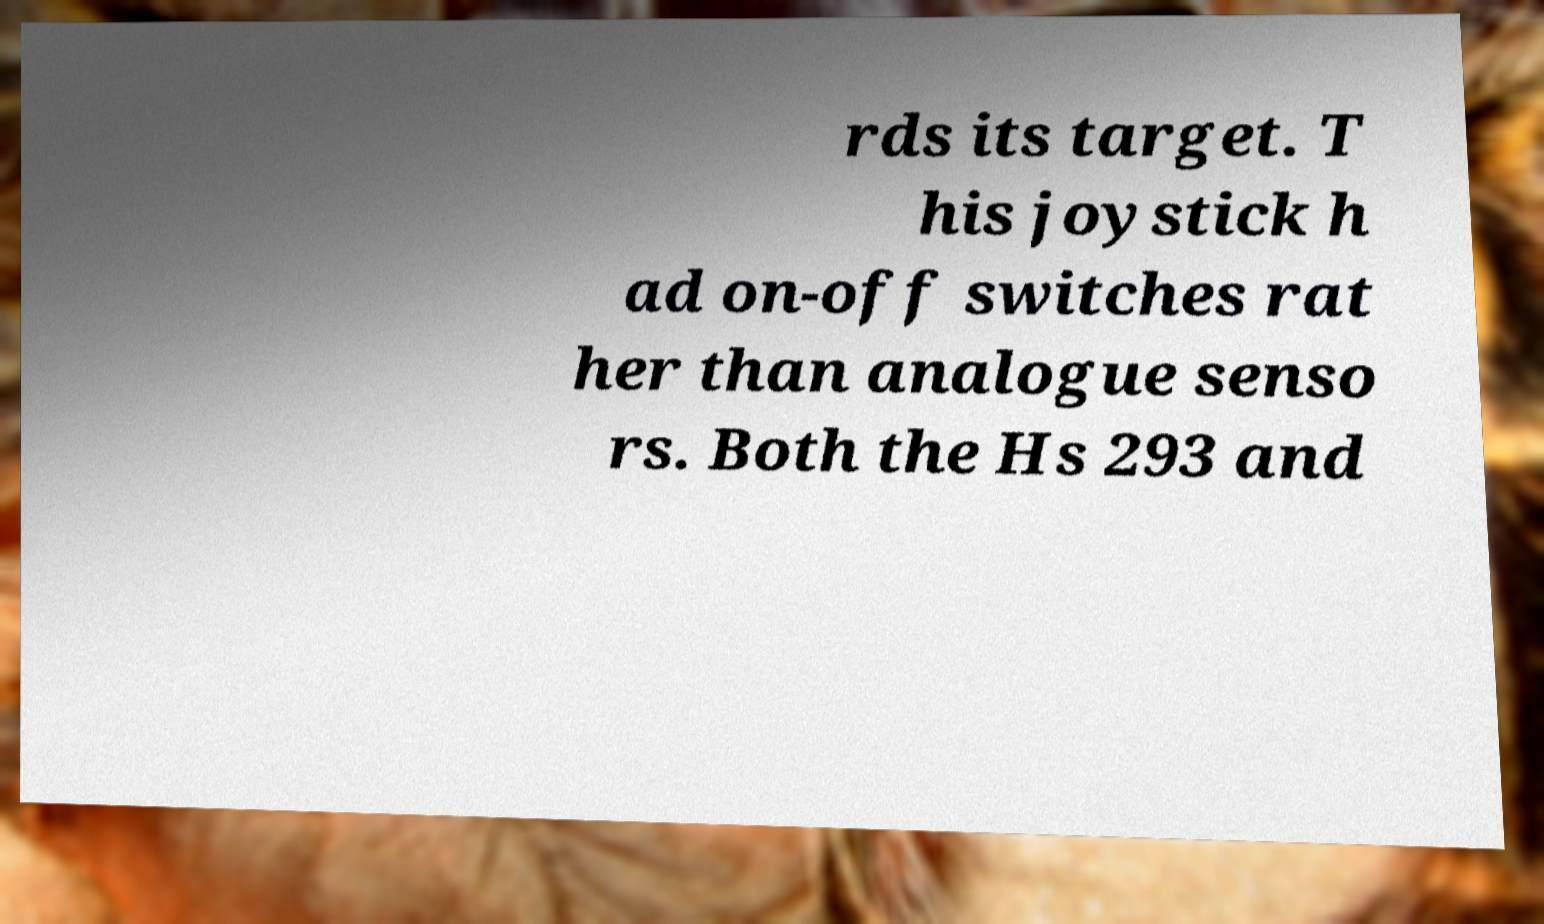What messages or text are displayed in this image? I need them in a readable, typed format. rds its target. T his joystick h ad on-off switches rat her than analogue senso rs. Both the Hs 293 and 